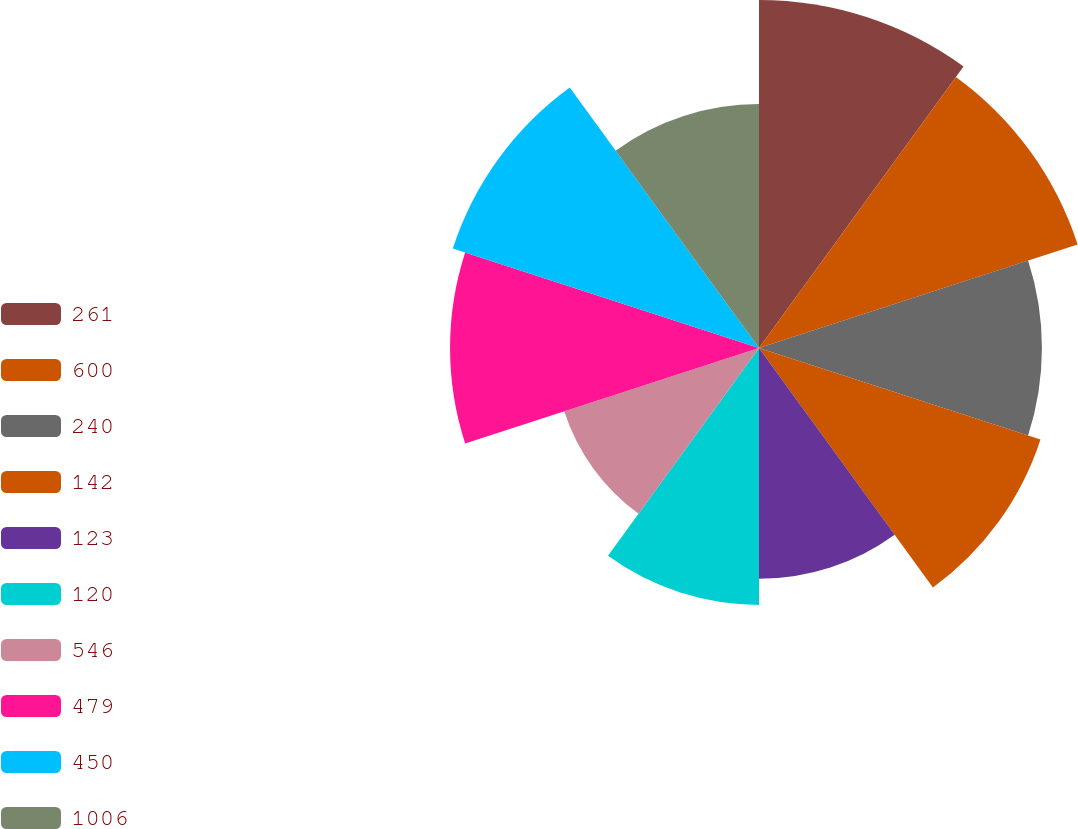Convert chart. <chart><loc_0><loc_0><loc_500><loc_500><pie_chart><fcel>261<fcel>600<fcel>240<fcel>142<fcel>123<fcel>120<fcel>546<fcel>479<fcel>450<fcel>1006<nl><fcel>12.3%<fcel>11.84%<fcel>10.0%<fcel>10.46%<fcel>8.16%<fcel>9.08%<fcel>7.24%<fcel>10.92%<fcel>11.38%<fcel>8.62%<nl></chart> 